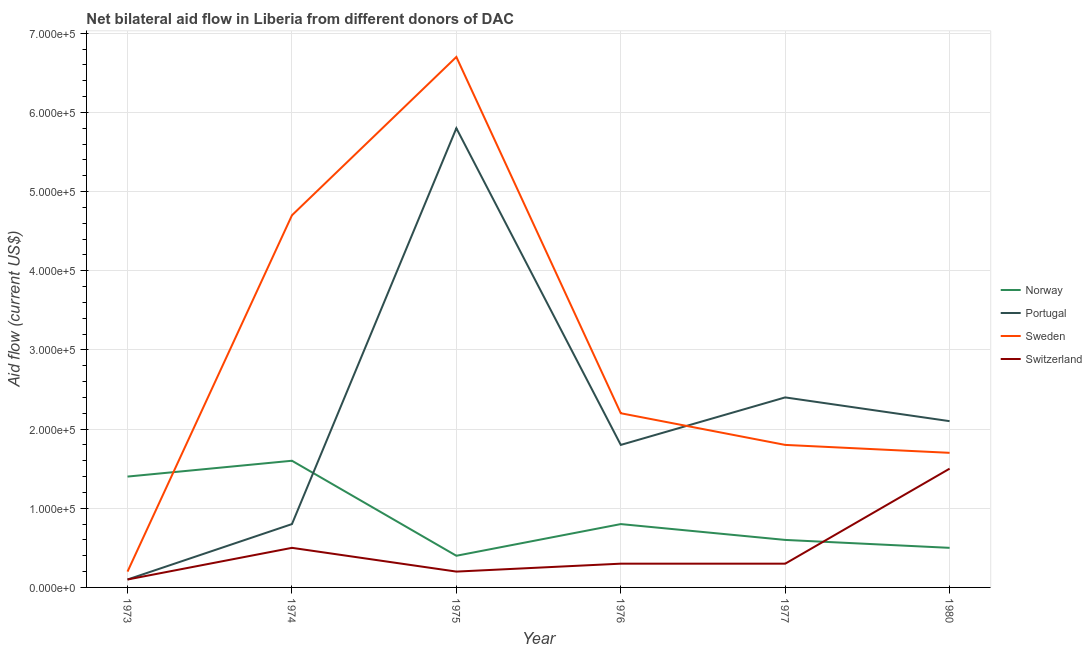How many different coloured lines are there?
Ensure brevity in your answer.  4. Does the line corresponding to amount of aid given by switzerland intersect with the line corresponding to amount of aid given by norway?
Ensure brevity in your answer.  Yes. Is the number of lines equal to the number of legend labels?
Offer a very short reply. Yes. What is the amount of aid given by sweden in 1974?
Provide a succinct answer. 4.70e+05. Across all years, what is the maximum amount of aid given by sweden?
Offer a terse response. 6.70e+05. Across all years, what is the minimum amount of aid given by sweden?
Provide a succinct answer. 2.00e+04. In which year was the amount of aid given by norway maximum?
Your response must be concise. 1974. What is the total amount of aid given by sweden in the graph?
Your answer should be very brief. 1.73e+06. What is the difference between the amount of aid given by switzerland in 1977 and that in 1980?
Your answer should be compact. -1.20e+05. What is the difference between the amount of aid given by norway in 1977 and the amount of aid given by sweden in 1973?
Provide a succinct answer. 4.00e+04. What is the average amount of aid given by sweden per year?
Your response must be concise. 2.88e+05. In the year 1976, what is the difference between the amount of aid given by switzerland and amount of aid given by portugal?
Offer a terse response. -1.50e+05. In how many years, is the amount of aid given by norway greater than 160000 US$?
Ensure brevity in your answer.  0. What is the ratio of the amount of aid given by switzerland in 1973 to that in 1975?
Make the answer very short. 0.5. What is the difference between the highest and the second highest amount of aid given by sweden?
Provide a succinct answer. 2.00e+05. What is the difference between the highest and the lowest amount of aid given by norway?
Your answer should be compact. 1.20e+05. Is it the case that in every year, the sum of the amount of aid given by norway and amount of aid given by sweden is greater than the sum of amount of aid given by portugal and amount of aid given by switzerland?
Provide a short and direct response. No. Does the amount of aid given by norway monotonically increase over the years?
Ensure brevity in your answer.  No. Is the amount of aid given by norway strictly greater than the amount of aid given by sweden over the years?
Your answer should be very brief. No. How many legend labels are there?
Give a very brief answer. 4. What is the title of the graph?
Your answer should be compact. Net bilateral aid flow in Liberia from different donors of DAC. What is the label or title of the X-axis?
Provide a succinct answer. Year. What is the Aid flow (current US$) in Norway in 1973?
Your answer should be compact. 1.40e+05. What is the Aid flow (current US$) in Portugal in 1973?
Offer a very short reply. 10000. What is the Aid flow (current US$) of Sweden in 1973?
Keep it short and to the point. 2.00e+04. What is the Aid flow (current US$) in Portugal in 1975?
Make the answer very short. 5.80e+05. What is the Aid flow (current US$) of Sweden in 1975?
Your answer should be very brief. 6.70e+05. What is the Aid flow (current US$) of Switzerland in 1975?
Provide a short and direct response. 2.00e+04. What is the Aid flow (current US$) of Norway in 1976?
Your response must be concise. 8.00e+04. What is the Aid flow (current US$) in Sweden in 1976?
Your response must be concise. 2.20e+05. What is the Aid flow (current US$) in Norway in 1977?
Provide a succinct answer. 6.00e+04. What is the Aid flow (current US$) in Portugal in 1977?
Make the answer very short. 2.40e+05. What is the Aid flow (current US$) of Sweden in 1977?
Your response must be concise. 1.80e+05. What is the Aid flow (current US$) of Switzerland in 1977?
Provide a short and direct response. 3.00e+04. What is the Aid flow (current US$) of Norway in 1980?
Your response must be concise. 5.00e+04. What is the Aid flow (current US$) in Portugal in 1980?
Give a very brief answer. 2.10e+05. What is the Aid flow (current US$) of Switzerland in 1980?
Offer a very short reply. 1.50e+05. Across all years, what is the maximum Aid flow (current US$) in Norway?
Your answer should be very brief. 1.60e+05. Across all years, what is the maximum Aid flow (current US$) of Portugal?
Provide a short and direct response. 5.80e+05. Across all years, what is the maximum Aid flow (current US$) of Sweden?
Keep it short and to the point. 6.70e+05. Across all years, what is the minimum Aid flow (current US$) of Portugal?
Provide a short and direct response. 10000. Across all years, what is the minimum Aid flow (current US$) in Sweden?
Keep it short and to the point. 2.00e+04. Across all years, what is the minimum Aid flow (current US$) of Switzerland?
Give a very brief answer. 10000. What is the total Aid flow (current US$) of Norway in the graph?
Make the answer very short. 5.30e+05. What is the total Aid flow (current US$) in Portugal in the graph?
Your response must be concise. 1.30e+06. What is the total Aid flow (current US$) in Sweden in the graph?
Ensure brevity in your answer.  1.73e+06. What is the total Aid flow (current US$) of Switzerland in the graph?
Keep it short and to the point. 2.90e+05. What is the difference between the Aid flow (current US$) of Norway in 1973 and that in 1974?
Offer a very short reply. -2.00e+04. What is the difference between the Aid flow (current US$) of Sweden in 1973 and that in 1974?
Your answer should be very brief. -4.50e+05. What is the difference between the Aid flow (current US$) of Switzerland in 1973 and that in 1974?
Ensure brevity in your answer.  -4.00e+04. What is the difference between the Aid flow (current US$) of Norway in 1973 and that in 1975?
Your answer should be very brief. 1.00e+05. What is the difference between the Aid flow (current US$) of Portugal in 1973 and that in 1975?
Your response must be concise. -5.70e+05. What is the difference between the Aid flow (current US$) in Sweden in 1973 and that in 1975?
Ensure brevity in your answer.  -6.50e+05. What is the difference between the Aid flow (current US$) of Switzerland in 1973 and that in 1975?
Provide a succinct answer. -10000. What is the difference between the Aid flow (current US$) in Norway in 1973 and that in 1976?
Give a very brief answer. 6.00e+04. What is the difference between the Aid flow (current US$) of Portugal in 1973 and that in 1976?
Provide a short and direct response. -1.70e+05. What is the difference between the Aid flow (current US$) in Switzerland in 1973 and that in 1976?
Provide a succinct answer. -2.00e+04. What is the difference between the Aid flow (current US$) of Portugal in 1973 and that in 1977?
Your answer should be very brief. -2.30e+05. What is the difference between the Aid flow (current US$) of Sweden in 1973 and that in 1977?
Your response must be concise. -1.60e+05. What is the difference between the Aid flow (current US$) of Switzerland in 1973 and that in 1977?
Make the answer very short. -2.00e+04. What is the difference between the Aid flow (current US$) in Norway in 1973 and that in 1980?
Give a very brief answer. 9.00e+04. What is the difference between the Aid flow (current US$) of Sweden in 1973 and that in 1980?
Offer a very short reply. -1.50e+05. What is the difference between the Aid flow (current US$) in Portugal in 1974 and that in 1975?
Make the answer very short. -5.00e+05. What is the difference between the Aid flow (current US$) of Switzerland in 1974 and that in 1975?
Your response must be concise. 3.00e+04. What is the difference between the Aid flow (current US$) of Norway in 1974 and that in 1976?
Make the answer very short. 8.00e+04. What is the difference between the Aid flow (current US$) of Portugal in 1974 and that in 1976?
Offer a terse response. -1.00e+05. What is the difference between the Aid flow (current US$) in Norway in 1974 and that in 1977?
Ensure brevity in your answer.  1.00e+05. What is the difference between the Aid flow (current US$) of Sweden in 1974 and that in 1977?
Keep it short and to the point. 2.90e+05. What is the difference between the Aid flow (current US$) in Portugal in 1974 and that in 1980?
Make the answer very short. -1.30e+05. What is the difference between the Aid flow (current US$) in Sweden in 1974 and that in 1980?
Offer a terse response. 3.00e+05. What is the difference between the Aid flow (current US$) of Switzerland in 1974 and that in 1980?
Give a very brief answer. -1.00e+05. What is the difference between the Aid flow (current US$) in Norway in 1975 and that in 1976?
Your response must be concise. -4.00e+04. What is the difference between the Aid flow (current US$) of Sweden in 1975 and that in 1976?
Offer a terse response. 4.50e+05. What is the difference between the Aid flow (current US$) of Norway in 1975 and that in 1977?
Provide a succinct answer. -2.00e+04. What is the difference between the Aid flow (current US$) in Sweden in 1975 and that in 1977?
Your response must be concise. 4.90e+05. What is the difference between the Aid flow (current US$) in Switzerland in 1975 and that in 1977?
Provide a succinct answer. -10000. What is the difference between the Aid flow (current US$) of Norway in 1975 and that in 1980?
Your response must be concise. -10000. What is the difference between the Aid flow (current US$) in Sweden in 1975 and that in 1980?
Make the answer very short. 5.00e+05. What is the difference between the Aid flow (current US$) in Norway in 1976 and that in 1977?
Offer a terse response. 2.00e+04. What is the difference between the Aid flow (current US$) in Sweden in 1976 and that in 1980?
Your response must be concise. 5.00e+04. What is the difference between the Aid flow (current US$) of Switzerland in 1976 and that in 1980?
Make the answer very short. -1.20e+05. What is the difference between the Aid flow (current US$) in Sweden in 1977 and that in 1980?
Give a very brief answer. 10000. What is the difference between the Aid flow (current US$) in Switzerland in 1977 and that in 1980?
Ensure brevity in your answer.  -1.20e+05. What is the difference between the Aid flow (current US$) in Norway in 1973 and the Aid flow (current US$) in Portugal in 1974?
Your answer should be very brief. 6.00e+04. What is the difference between the Aid flow (current US$) of Norway in 1973 and the Aid flow (current US$) of Sweden in 1974?
Provide a short and direct response. -3.30e+05. What is the difference between the Aid flow (current US$) of Portugal in 1973 and the Aid flow (current US$) of Sweden in 1974?
Your response must be concise. -4.60e+05. What is the difference between the Aid flow (current US$) of Norway in 1973 and the Aid flow (current US$) of Portugal in 1975?
Make the answer very short. -4.40e+05. What is the difference between the Aid flow (current US$) in Norway in 1973 and the Aid flow (current US$) in Sweden in 1975?
Provide a short and direct response. -5.30e+05. What is the difference between the Aid flow (current US$) in Portugal in 1973 and the Aid flow (current US$) in Sweden in 1975?
Keep it short and to the point. -6.60e+05. What is the difference between the Aid flow (current US$) in Sweden in 1973 and the Aid flow (current US$) in Switzerland in 1975?
Provide a succinct answer. 0. What is the difference between the Aid flow (current US$) of Norway in 1973 and the Aid flow (current US$) of Sweden in 1976?
Give a very brief answer. -8.00e+04. What is the difference between the Aid flow (current US$) of Portugal in 1973 and the Aid flow (current US$) of Sweden in 1976?
Provide a short and direct response. -2.10e+05. What is the difference between the Aid flow (current US$) in Norway in 1973 and the Aid flow (current US$) in Sweden in 1977?
Provide a short and direct response. -4.00e+04. What is the difference between the Aid flow (current US$) of Portugal in 1973 and the Aid flow (current US$) of Sweden in 1977?
Keep it short and to the point. -1.70e+05. What is the difference between the Aid flow (current US$) of Sweden in 1973 and the Aid flow (current US$) of Switzerland in 1977?
Your answer should be compact. -10000. What is the difference between the Aid flow (current US$) in Norway in 1973 and the Aid flow (current US$) in Portugal in 1980?
Make the answer very short. -7.00e+04. What is the difference between the Aid flow (current US$) in Norway in 1973 and the Aid flow (current US$) in Sweden in 1980?
Offer a very short reply. -3.00e+04. What is the difference between the Aid flow (current US$) of Norway in 1973 and the Aid flow (current US$) of Switzerland in 1980?
Your response must be concise. -10000. What is the difference between the Aid flow (current US$) in Norway in 1974 and the Aid flow (current US$) in Portugal in 1975?
Keep it short and to the point. -4.20e+05. What is the difference between the Aid flow (current US$) of Norway in 1974 and the Aid flow (current US$) of Sweden in 1975?
Give a very brief answer. -5.10e+05. What is the difference between the Aid flow (current US$) in Portugal in 1974 and the Aid flow (current US$) in Sweden in 1975?
Your response must be concise. -5.90e+05. What is the difference between the Aid flow (current US$) of Sweden in 1974 and the Aid flow (current US$) of Switzerland in 1975?
Keep it short and to the point. 4.50e+05. What is the difference between the Aid flow (current US$) of Norway in 1974 and the Aid flow (current US$) of Portugal in 1976?
Offer a very short reply. -2.00e+04. What is the difference between the Aid flow (current US$) of Norway in 1974 and the Aid flow (current US$) of Switzerland in 1976?
Make the answer very short. 1.30e+05. What is the difference between the Aid flow (current US$) in Portugal in 1974 and the Aid flow (current US$) in Sweden in 1976?
Provide a short and direct response. -1.40e+05. What is the difference between the Aid flow (current US$) of Norway in 1974 and the Aid flow (current US$) of Switzerland in 1977?
Keep it short and to the point. 1.30e+05. What is the difference between the Aid flow (current US$) of Portugal in 1974 and the Aid flow (current US$) of Sweden in 1977?
Your answer should be very brief. -1.00e+05. What is the difference between the Aid flow (current US$) in Portugal in 1974 and the Aid flow (current US$) in Switzerland in 1977?
Provide a succinct answer. 5.00e+04. What is the difference between the Aid flow (current US$) of Sweden in 1974 and the Aid flow (current US$) of Switzerland in 1977?
Your answer should be compact. 4.40e+05. What is the difference between the Aid flow (current US$) in Norway in 1974 and the Aid flow (current US$) in Sweden in 1980?
Offer a terse response. -10000. What is the difference between the Aid flow (current US$) in Portugal in 1974 and the Aid flow (current US$) in Sweden in 1980?
Your answer should be compact. -9.00e+04. What is the difference between the Aid flow (current US$) of Portugal in 1974 and the Aid flow (current US$) of Switzerland in 1980?
Your answer should be compact. -7.00e+04. What is the difference between the Aid flow (current US$) in Norway in 1975 and the Aid flow (current US$) in Sweden in 1976?
Make the answer very short. -1.80e+05. What is the difference between the Aid flow (current US$) of Norway in 1975 and the Aid flow (current US$) of Switzerland in 1976?
Provide a succinct answer. 10000. What is the difference between the Aid flow (current US$) in Portugal in 1975 and the Aid flow (current US$) in Sweden in 1976?
Offer a terse response. 3.60e+05. What is the difference between the Aid flow (current US$) of Sweden in 1975 and the Aid flow (current US$) of Switzerland in 1976?
Offer a terse response. 6.40e+05. What is the difference between the Aid flow (current US$) in Norway in 1975 and the Aid flow (current US$) in Switzerland in 1977?
Provide a succinct answer. 10000. What is the difference between the Aid flow (current US$) in Portugal in 1975 and the Aid flow (current US$) in Sweden in 1977?
Provide a succinct answer. 4.00e+05. What is the difference between the Aid flow (current US$) in Sweden in 1975 and the Aid flow (current US$) in Switzerland in 1977?
Your answer should be compact. 6.40e+05. What is the difference between the Aid flow (current US$) in Norway in 1975 and the Aid flow (current US$) in Portugal in 1980?
Your answer should be very brief. -1.70e+05. What is the difference between the Aid flow (current US$) in Norway in 1975 and the Aid flow (current US$) in Sweden in 1980?
Your response must be concise. -1.30e+05. What is the difference between the Aid flow (current US$) of Norway in 1975 and the Aid flow (current US$) of Switzerland in 1980?
Ensure brevity in your answer.  -1.10e+05. What is the difference between the Aid flow (current US$) in Portugal in 1975 and the Aid flow (current US$) in Sweden in 1980?
Your answer should be compact. 4.10e+05. What is the difference between the Aid flow (current US$) in Portugal in 1975 and the Aid flow (current US$) in Switzerland in 1980?
Offer a terse response. 4.30e+05. What is the difference between the Aid flow (current US$) of Sweden in 1975 and the Aid flow (current US$) of Switzerland in 1980?
Provide a short and direct response. 5.20e+05. What is the difference between the Aid flow (current US$) in Portugal in 1976 and the Aid flow (current US$) in Switzerland in 1977?
Keep it short and to the point. 1.50e+05. What is the difference between the Aid flow (current US$) in Norway in 1976 and the Aid flow (current US$) in Portugal in 1980?
Offer a very short reply. -1.30e+05. What is the difference between the Aid flow (current US$) in Norway in 1976 and the Aid flow (current US$) in Sweden in 1980?
Offer a very short reply. -9.00e+04. What is the difference between the Aid flow (current US$) of Norway in 1976 and the Aid flow (current US$) of Switzerland in 1980?
Ensure brevity in your answer.  -7.00e+04. What is the difference between the Aid flow (current US$) of Sweden in 1976 and the Aid flow (current US$) of Switzerland in 1980?
Your response must be concise. 7.00e+04. What is the difference between the Aid flow (current US$) of Norway in 1977 and the Aid flow (current US$) of Portugal in 1980?
Ensure brevity in your answer.  -1.50e+05. What is the difference between the Aid flow (current US$) in Norway in 1977 and the Aid flow (current US$) in Switzerland in 1980?
Your answer should be compact. -9.00e+04. What is the average Aid flow (current US$) in Norway per year?
Your answer should be very brief. 8.83e+04. What is the average Aid flow (current US$) in Portugal per year?
Your answer should be very brief. 2.17e+05. What is the average Aid flow (current US$) in Sweden per year?
Offer a terse response. 2.88e+05. What is the average Aid flow (current US$) of Switzerland per year?
Make the answer very short. 4.83e+04. In the year 1973, what is the difference between the Aid flow (current US$) of Norway and Aid flow (current US$) of Portugal?
Ensure brevity in your answer.  1.30e+05. In the year 1973, what is the difference between the Aid flow (current US$) in Norway and Aid flow (current US$) in Switzerland?
Give a very brief answer. 1.30e+05. In the year 1973, what is the difference between the Aid flow (current US$) in Portugal and Aid flow (current US$) in Sweden?
Your answer should be very brief. -10000. In the year 1974, what is the difference between the Aid flow (current US$) of Norway and Aid flow (current US$) of Portugal?
Your answer should be very brief. 8.00e+04. In the year 1974, what is the difference between the Aid flow (current US$) in Norway and Aid flow (current US$) in Sweden?
Provide a short and direct response. -3.10e+05. In the year 1974, what is the difference between the Aid flow (current US$) in Portugal and Aid flow (current US$) in Sweden?
Offer a terse response. -3.90e+05. In the year 1974, what is the difference between the Aid flow (current US$) of Sweden and Aid flow (current US$) of Switzerland?
Give a very brief answer. 4.20e+05. In the year 1975, what is the difference between the Aid flow (current US$) in Norway and Aid flow (current US$) in Portugal?
Keep it short and to the point. -5.40e+05. In the year 1975, what is the difference between the Aid flow (current US$) of Norway and Aid flow (current US$) of Sweden?
Your response must be concise. -6.30e+05. In the year 1975, what is the difference between the Aid flow (current US$) in Portugal and Aid flow (current US$) in Switzerland?
Your answer should be very brief. 5.60e+05. In the year 1975, what is the difference between the Aid flow (current US$) of Sweden and Aid flow (current US$) of Switzerland?
Your answer should be very brief. 6.50e+05. In the year 1976, what is the difference between the Aid flow (current US$) of Norway and Aid flow (current US$) of Switzerland?
Offer a very short reply. 5.00e+04. In the year 1977, what is the difference between the Aid flow (current US$) of Portugal and Aid flow (current US$) of Sweden?
Provide a short and direct response. 6.00e+04. In the year 1977, what is the difference between the Aid flow (current US$) of Portugal and Aid flow (current US$) of Switzerland?
Give a very brief answer. 2.10e+05. In the year 1977, what is the difference between the Aid flow (current US$) of Sweden and Aid flow (current US$) of Switzerland?
Make the answer very short. 1.50e+05. In the year 1980, what is the difference between the Aid flow (current US$) of Norway and Aid flow (current US$) of Portugal?
Provide a short and direct response. -1.60e+05. In the year 1980, what is the difference between the Aid flow (current US$) of Portugal and Aid flow (current US$) of Sweden?
Offer a very short reply. 4.00e+04. What is the ratio of the Aid flow (current US$) in Portugal in 1973 to that in 1974?
Your response must be concise. 0.12. What is the ratio of the Aid flow (current US$) of Sweden in 1973 to that in 1974?
Provide a succinct answer. 0.04. What is the ratio of the Aid flow (current US$) in Norway in 1973 to that in 1975?
Offer a very short reply. 3.5. What is the ratio of the Aid flow (current US$) in Portugal in 1973 to that in 1975?
Keep it short and to the point. 0.02. What is the ratio of the Aid flow (current US$) of Sweden in 1973 to that in 1975?
Give a very brief answer. 0.03. What is the ratio of the Aid flow (current US$) in Switzerland in 1973 to that in 1975?
Make the answer very short. 0.5. What is the ratio of the Aid flow (current US$) in Portugal in 1973 to that in 1976?
Your answer should be compact. 0.06. What is the ratio of the Aid flow (current US$) in Sweden in 1973 to that in 1976?
Provide a succinct answer. 0.09. What is the ratio of the Aid flow (current US$) of Switzerland in 1973 to that in 1976?
Your response must be concise. 0.33. What is the ratio of the Aid flow (current US$) of Norway in 1973 to that in 1977?
Keep it short and to the point. 2.33. What is the ratio of the Aid flow (current US$) of Portugal in 1973 to that in 1977?
Provide a short and direct response. 0.04. What is the ratio of the Aid flow (current US$) of Sweden in 1973 to that in 1977?
Your answer should be very brief. 0.11. What is the ratio of the Aid flow (current US$) in Switzerland in 1973 to that in 1977?
Provide a short and direct response. 0.33. What is the ratio of the Aid flow (current US$) of Portugal in 1973 to that in 1980?
Your answer should be compact. 0.05. What is the ratio of the Aid flow (current US$) of Sweden in 1973 to that in 1980?
Provide a succinct answer. 0.12. What is the ratio of the Aid flow (current US$) of Switzerland in 1973 to that in 1980?
Give a very brief answer. 0.07. What is the ratio of the Aid flow (current US$) in Norway in 1974 to that in 1975?
Your answer should be compact. 4. What is the ratio of the Aid flow (current US$) in Portugal in 1974 to that in 1975?
Your answer should be very brief. 0.14. What is the ratio of the Aid flow (current US$) in Sweden in 1974 to that in 1975?
Your answer should be compact. 0.7. What is the ratio of the Aid flow (current US$) of Switzerland in 1974 to that in 1975?
Provide a short and direct response. 2.5. What is the ratio of the Aid flow (current US$) of Portugal in 1974 to that in 1976?
Your answer should be compact. 0.44. What is the ratio of the Aid flow (current US$) of Sweden in 1974 to that in 1976?
Your answer should be compact. 2.14. What is the ratio of the Aid flow (current US$) of Norway in 1974 to that in 1977?
Keep it short and to the point. 2.67. What is the ratio of the Aid flow (current US$) of Portugal in 1974 to that in 1977?
Give a very brief answer. 0.33. What is the ratio of the Aid flow (current US$) in Sweden in 1974 to that in 1977?
Provide a succinct answer. 2.61. What is the ratio of the Aid flow (current US$) in Norway in 1974 to that in 1980?
Your answer should be very brief. 3.2. What is the ratio of the Aid flow (current US$) in Portugal in 1974 to that in 1980?
Provide a succinct answer. 0.38. What is the ratio of the Aid flow (current US$) in Sweden in 1974 to that in 1980?
Offer a very short reply. 2.76. What is the ratio of the Aid flow (current US$) in Norway in 1975 to that in 1976?
Your response must be concise. 0.5. What is the ratio of the Aid flow (current US$) of Portugal in 1975 to that in 1976?
Offer a very short reply. 3.22. What is the ratio of the Aid flow (current US$) in Sweden in 1975 to that in 1976?
Provide a short and direct response. 3.05. What is the ratio of the Aid flow (current US$) of Portugal in 1975 to that in 1977?
Make the answer very short. 2.42. What is the ratio of the Aid flow (current US$) of Sweden in 1975 to that in 1977?
Provide a short and direct response. 3.72. What is the ratio of the Aid flow (current US$) in Portugal in 1975 to that in 1980?
Your response must be concise. 2.76. What is the ratio of the Aid flow (current US$) in Sweden in 1975 to that in 1980?
Your answer should be very brief. 3.94. What is the ratio of the Aid flow (current US$) of Switzerland in 1975 to that in 1980?
Provide a succinct answer. 0.13. What is the ratio of the Aid flow (current US$) in Sweden in 1976 to that in 1977?
Offer a very short reply. 1.22. What is the ratio of the Aid flow (current US$) of Switzerland in 1976 to that in 1977?
Keep it short and to the point. 1. What is the ratio of the Aid flow (current US$) of Norway in 1976 to that in 1980?
Provide a short and direct response. 1.6. What is the ratio of the Aid flow (current US$) of Portugal in 1976 to that in 1980?
Provide a succinct answer. 0.86. What is the ratio of the Aid flow (current US$) of Sweden in 1976 to that in 1980?
Offer a terse response. 1.29. What is the ratio of the Aid flow (current US$) of Switzerland in 1976 to that in 1980?
Offer a terse response. 0.2. What is the ratio of the Aid flow (current US$) of Portugal in 1977 to that in 1980?
Keep it short and to the point. 1.14. What is the ratio of the Aid flow (current US$) in Sweden in 1977 to that in 1980?
Your answer should be very brief. 1.06. What is the ratio of the Aid flow (current US$) in Switzerland in 1977 to that in 1980?
Keep it short and to the point. 0.2. What is the difference between the highest and the second highest Aid flow (current US$) of Norway?
Provide a succinct answer. 2.00e+04. What is the difference between the highest and the lowest Aid flow (current US$) of Norway?
Your answer should be compact. 1.20e+05. What is the difference between the highest and the lowest Aid flow (current US$) of Portugal?
Provide a short and direct response. 5.70e+05. What is the difference between the highest and the lowest Aid flow (current US$) of Sweden?
Offer a terse response. 6.50e+05. What is the difference between the highest and the lowest Aid flow (current US$) of Switzerland?
Offer a very short reply. 1.40e+05. 